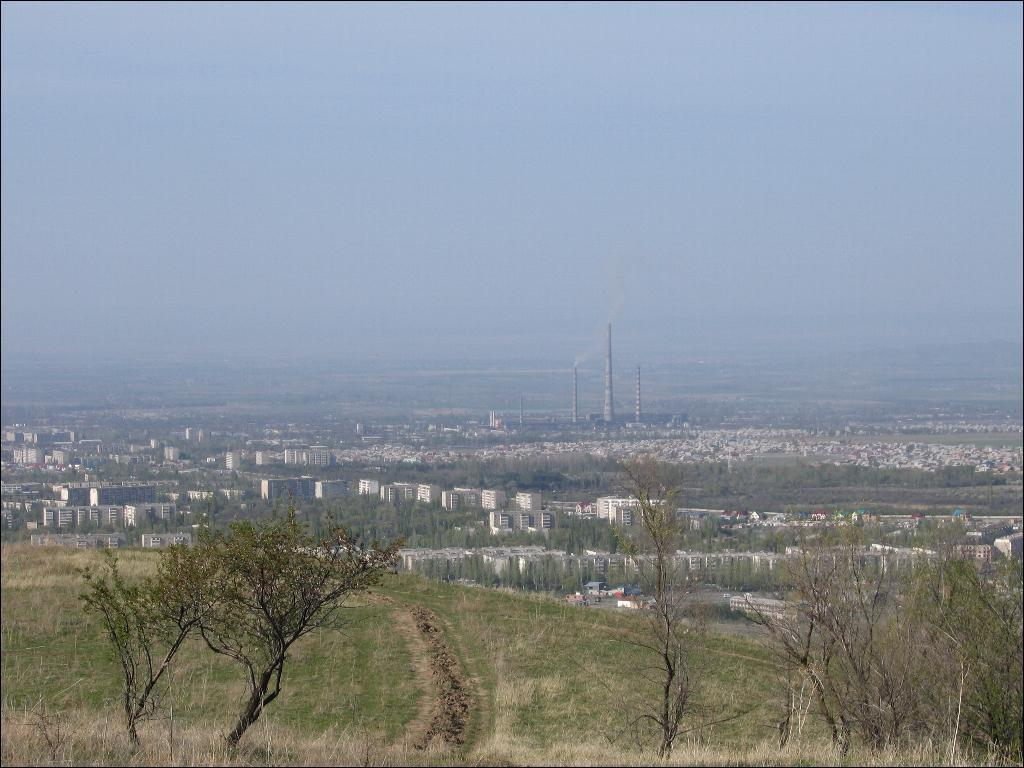What type of vegetation is in the foreground of the image? There is grass and trees in the foreground of the image. What can be seen in the background of the image? There are trees, buildings, and towers in the background of the image. What is visible at the top of the image? The sky is visible at the top of the image. What is the opinion of the grass in the image? The grass in the image does not have an opinion, as it is a non-living object. What type of wood can be seen in the image? There is no wood present in the image; it features grass, trees, a city, and the sky. 